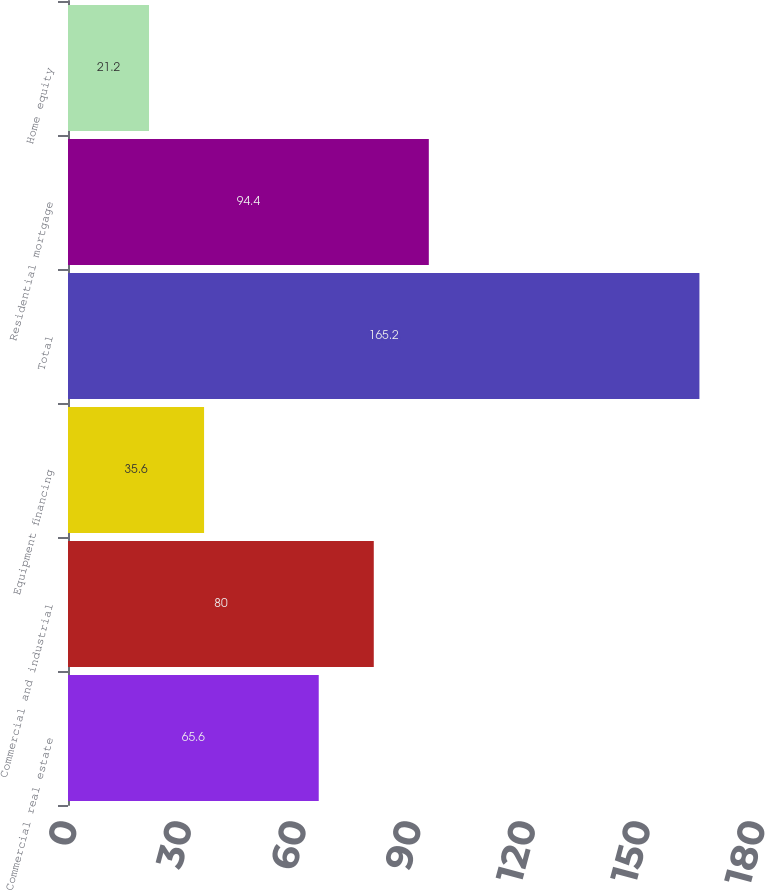Convert chart to OTSL. <chart><loc_0><loc_0><loc_500><loc_500><bar_chart><fcel>Commercial real estate<fcel>Commercial and industrial<fcel>Equipment financing<fcel>Total<fcel>Residential mortgage<fcel>Home equity<nl><fcel>65.6<fcel>80<fcel>35.6<fcel>165.2<fcel>94.4<fcel>21.2<nl></chart> 